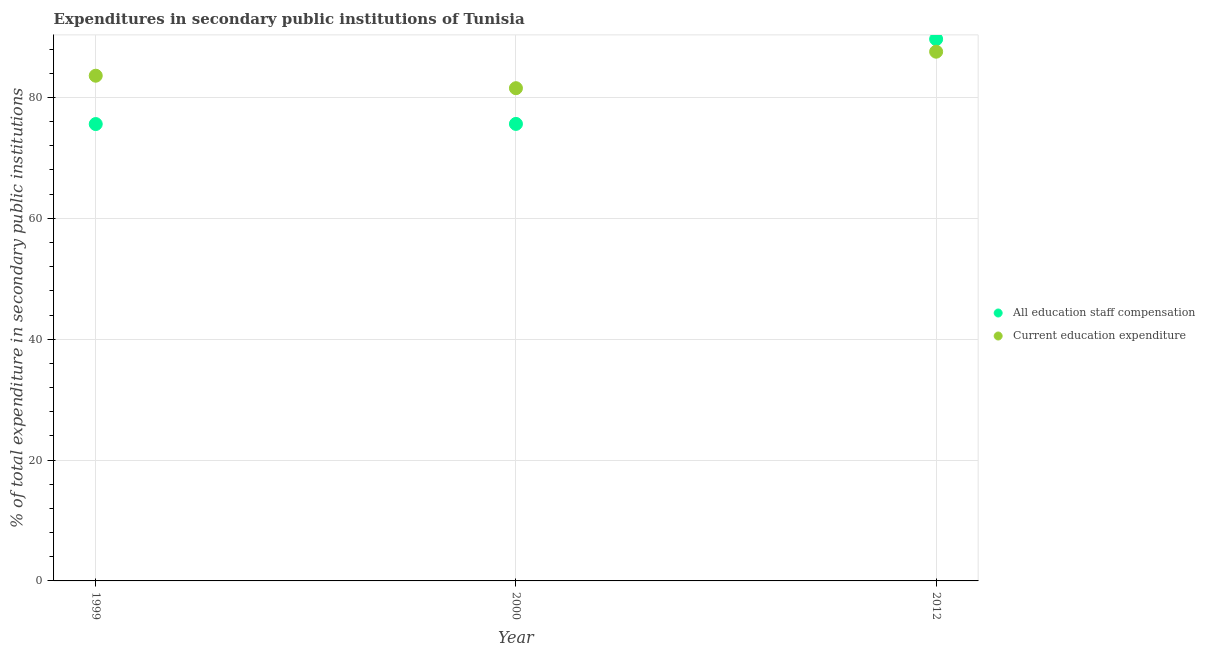How many different coloured dotlines are there?
Keep it short and to the point. 2. Is the number of dotlines equal to the number of legend labels?
Your response must be concise. Yes. What is the expenditure in staff compensation in 2012?
Give a very brief answer. 89.65. Across all years, what is the maximum expenditure in education?
Keep it short and to the point. 87.57. Across all years, what is the minimum expenditure in staff compensation?
Your answer should be very brief. 75.6. What is the total expenditure in education in the graph?
Your response must be concise. 252.71. What is the difference between the expenditure in education in 2000 and that in 2012?
Provide a succinct answer. -6.04. What is the difference between the expenditure in staff compensation in 1999 and the expenditure in education in 2012?
Offer a terse response. -11.97. What is the average expenditure in staff compensation per year?
Your answer should be very brief. 80.29. In the year 2012, what is the difference between the expenditure in staff compensation and expenditure in education?
Your answer should be compact. 2.08. In how many years, is the expenditure in education greater than 72 %?
Keep it short and to the point. 3. What is the ratio of the expenditure in staff compensation in 1999 to that in 2000?
Make the answer very short. 1. Is the expenditure in staff compensation in 2000 less than that in 2012?
Provide a short and direct response. Yes. Is the difference between the expenditure in education in 1999 and 2012 greater than the difference between the expenditure in staff compensation in 1999 and 2012?
Ensure brevity in your answer.  Yes. What is the difference between the highest and the second highest expenditure in staff compensation?
Offer a terse response. 14.03. What is the difference between the highest and the lowest expenditure in education?
Keep it short and to the point. 6.04. In how many years, is the expenditure in education greater than the average expenditure in education taken over all years?
Keep it short and to the point. 1. Does the expenditure in staff compensation monotonically increase over the years?
Give a very brief answer. Yes. What is the difference between two consecutive major ticks on the Y-axis?
Make the answer very short. 20. Are the values on the major ticks of Y-axis written in scientific E-notation?
Ensure brevity in your answer.  No. Does the graph contain any zero values?
Make the answer very short. No. How many legend labels are there?
Provide a short and direct response. 2. What is the title of the graph?
Keep it short and to the point. Expenditures in secondary public institutions of Tunisia. What is the label or title of the X-axis?
Offer a terse response. Year. What is the label or title of the Y-axis?
Your answer should be compact. % of total expenditure in secondary public institutions. What is the % of total expenditure in secondary public institutions in All education staff compensation in 1999?
Make the answer very short. 75.6. What is the % of total expenditure in secondary public institutions of Current education expenditure in 1999?
Offer a terse response. 83.6. What is the % of total expenditure in secondary public institutions of All education staff compensation in 2000?
Provide a succinct answer. 75.62. What is the % of total expenditure in secondary public institutions in Current education expenditure in 2000?
Ensure brevity in your answer.  81.53. What is the % of total expenditure in secondary public institutions of All education staff compensation in 2012?
Keep it short and to the point. 89.65. What is the % of total expenditure in secondary public institutions of Current education expenditure in 2012?
Provide a succinct answer. 87.57. Across all years, what is the maximum % of total expenditure in secondary public institutions in All education staff compensation?
Keep it short and to the point. 89.65. Across all years, what is the maximum % of total expenditure in secondary public institutions in Current education expenditure?
Offer a very short reply. 87.57. Across all years, what is the minimum % of total expenditure in secondary public institutions of All education staff compensation?
Provide a succinct answer. 75.6. Across all years, what is the minimum % of total expenditure in secondary public institutions of Current education expenditure?
Provide a succinct answer. 81.53. What is the total % of total expenditure in secondary public institutions of All education staff compensation in the graph?
Your response must be concise. 240.88. What is the total % of total expenditure in secondary public institutions in Current education expenditure in the graph?
Make the answer very short. 252.71. What is the difference between the % of total expenditure in secondary public institutions of All education staff compensation in 1999 and that in 2000?
Offer a very short reply. -0.02. What is the difference between the % of total expenditure in secondary public institutions in Current education expenditure in 1999 and that in 2000?
Give a very brief answer. 2.07. What is the difference between the % of total expenditure in secondary public institutions of All education staff compensation in 1999 and that in 2012?
Give a very brief answer. -14.05. What is the difference between the % of total expenditure in secondary public institutions of Current education expenditure in 1999 and that in 2012?
Provide a succinct answer. -3.97. What is the difference between the % of total expenditure in secondary public institutions of All education staff compensation in 2000 and that in 2012?
Your answer should be very brief. -14.03. What is the difference between the % of total expenditure in secondary public institutions in Current education expenditure in 2000 and that in 2012?
Your response must be concise. -6.04. What is the difference between the % of total expenditure in secondary public institutions in All education staff compensation in 1999 and the % of total expenditure in secondary public institutions in Current education expenditure in 2000?
Your answer should be compact. -5.93. What is the difference between the % of total expenditure in secondary public institutions of All education staff compensation in 1999 and the % of total expenditure in secondary public institutions of Current education expenditure in 2012?
Your response must be concise. -11.97. What is the difference between the % of total expenditure in secondary public institutions of All education staff compensation in 2000 and the % of total expenditure in secondary public institutions of Current education expenditure in 2012?
Provide a succinct answer. -11.95. What is the average % of total expenditure in secondary public institutions in All education staff compensation per year?
Ensure brevity in your answer.  80.29. What is the average % of total expenditure in secondary public institutions of Current education expenditure per year?
Offer a terse response. 84.24. In the year 2000, what is the difference between the % of total expenditure in secondary public institutions of All education staff compensation and % of total expenditure in secondary public institutions of Current education expenditure?
Your answer should be compact. -5.91. In the year 2012, what is the difference between the % of total expenditure in secondary public institutions in All education staff compensation and % of total expenditure in secondary public institutions in Current education expenditure?
Your answer should be compact. 2.08. What is the ratio of the % of total expenditure in secondary public institutions of Current education expenditure in 1999 to that in 2000?
Keep it short and to the point. 1.03. What is the ratio of the % of total expenditure in secondary public institutions of All education staff compensation in 1999 to that in 2012?
Offer a terse response. 0.84. What is the ratio of the % of total expenditure in secondary public institutions in Current education expenditure in 1999 to that in 2012?
Provide a succinct answer. 0.95. What is the ratio of the % of total expenditure in secondary public institutions of All education staff compensation in 2000 to that in 2012?
Offer a very short reply. 0.84. What is the difference between the highest and the second highest % of total expenditure in secondary public institutions of All education staff compensation?
Provide a short and direct response. 14.03. What is the difference between the highest and the second highest % of total expenditure in secondary public institutions in Current education expenditure?
Provide a short and direct response. 3.97. What is the difference between the highest and the lowest % of total expenditure in secondary public institutions of All education staff compensation?
Make the answer very short. 14.05. What is the difference between the highest and the lowest % of total expenditure in secondary public institutions of Current education expenditure?
Offer a very short reply. 6.04. 